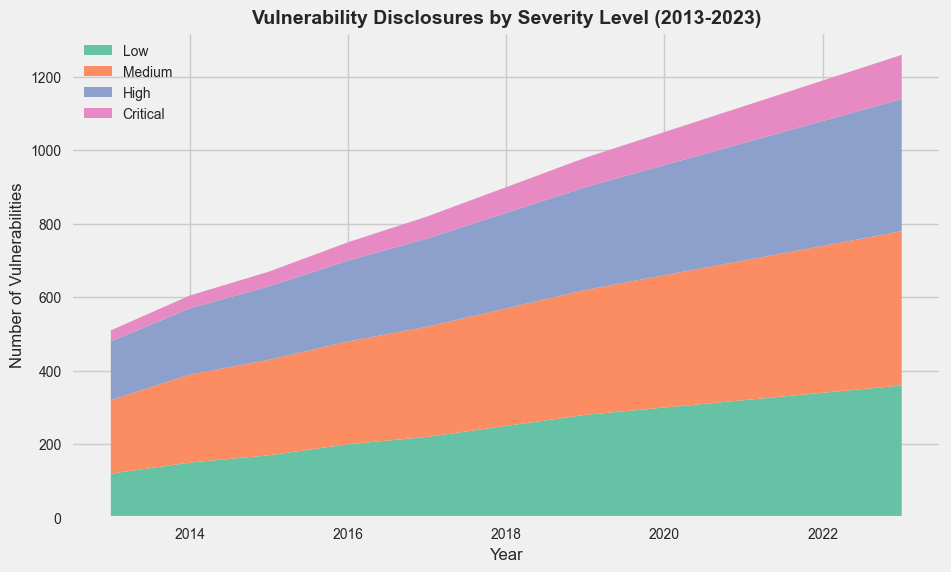What is the overall trend of critical vulnerabilities from 2013 to 2023? By observing the area representing critical vulnerabilities, it is clear that the number of critical vulnerabilities has been gradually increasing over the years from 30 in 2013 to 120 in 2023.
Answer: An increasing trend In which year did the number of medium-level vulnerabilities surpass 300? By looking at the graph, the area marked for medium vulnerabilities surpasses the 300 mark in the year 2017.
Answer: 2017 Which severity level had the highest number of vulnerabilities disclosed in 2023? By comparing the heights of the areas for different severity levels at the year 2023, it is evident that the medium-level vulnerabilities had the highest count.
Answer: Medium What is the difference in the number of low-level vulnerabilities between 2013 and 2023? The count of low-level vulnerabilities in 2023 is 360, and in 2013 it is 120. The difference is calculated as 360 - 120.
Answer: 240 How many high-level vulnerabilities were disclosed in total over the decade? Summing up the high-level vulnerabilities across all years from 2013 to 2023 gives the total: 160 + 180 + 200 + 220 + 240 + 260 + 280 + 300 + 320 + 340 + 360 = 2860.
Answer: 2860 Which year had the smallest number of critical vulnerabilities, and what was it? The smallest count of critical vulnerabilities occurs in the year 2013 with a value of 30.
Answer: 2013, 30 What are the visual cues used to differentiate between the severity levels in the chart? The chart uses different colors to represent each severity level: light green for low, orange for medium, blue for high, and pink for critical vulnerabilities.
Answer: Different colors What is the sum of vulnerabilities for the year 2020? Adding up all severities for the year 2020: 300 (low) + 360 (medium) + 300 (high) + 90 (critical) = 1050.
Answer: 1050 